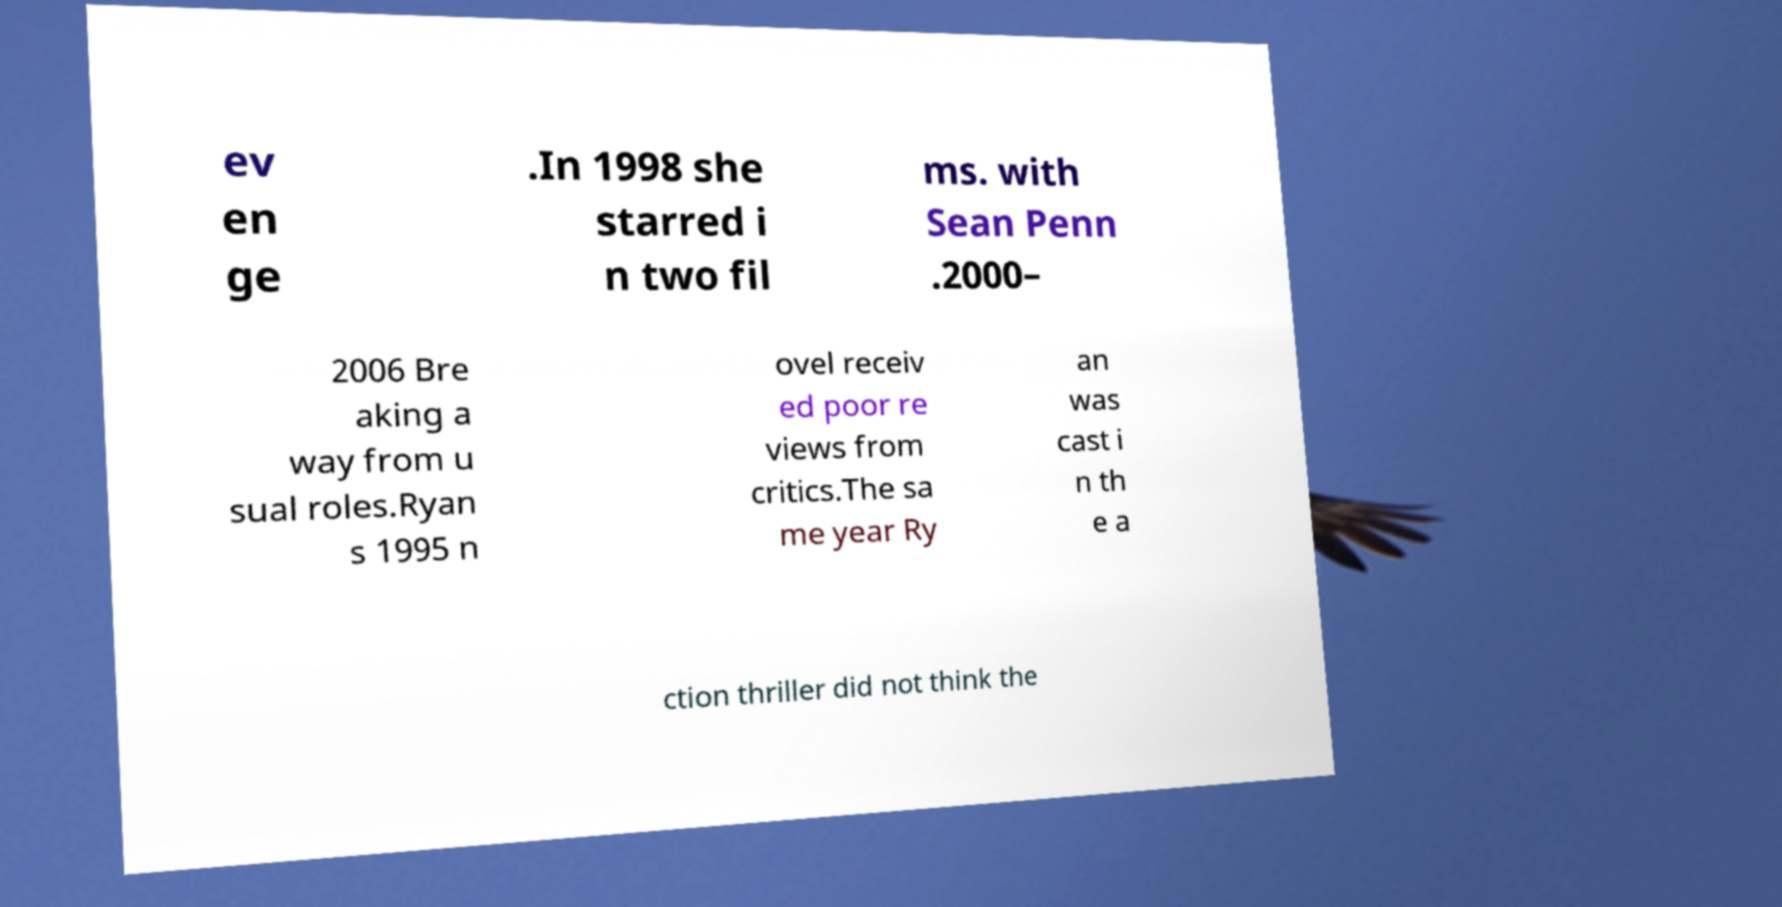Please read and relay the text visible in this image. What does it say? ev en ge .In 1998 she starred i n two fil ms. with Sean Penn .2000– 2006 Bre aking a way from u sual roles.Ryan s 1995 n ovel receiv ed poor re views from critics.The sa me year Ry an was cast i n th e a ction thriller did not think the 